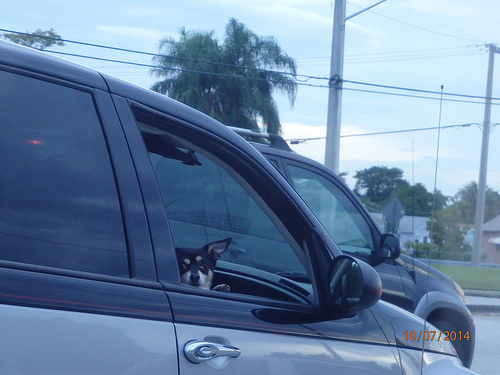<image>
Is there a dog to the left of the mirror? Yes. From this viewpoint, the dog is positioned to the left side relative to the mirror. 